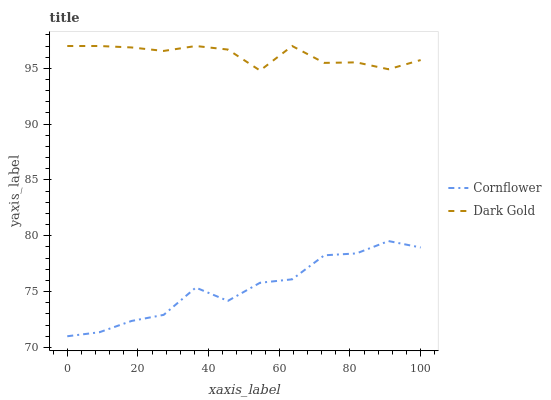Does Cornflower have the minimum area under the curve?
Answer yes or no. Yes. Does Dark Gold have the maximum area under the curve?
Answer yes or no. Yes. Does Dark Gold have the minimum area under the curve?
Answer yes or no. No. Is Dark Gold the smoothest?
Answer yes or no. Yes. Is Cornflower the roughest?
Answer yes or no. Yes. Is Dark Gold the roughest?
Answer yes or no. No. Does Cornflower have the lowest value?
Answer yes or no. Yes. Does Dark Gold have the lowest value?
Answer yes or no. No. Does Dark Gold have the highest value?
Answer yes or no. Yes. Is Cornflower less than Dark Gold?
Answer yes or no. Yes. Is Dark Gold greater than Cornflower?
Answer yes or no. Yes. Does Cornflower intersect Dark Gold?
Answer yes or no. No. 